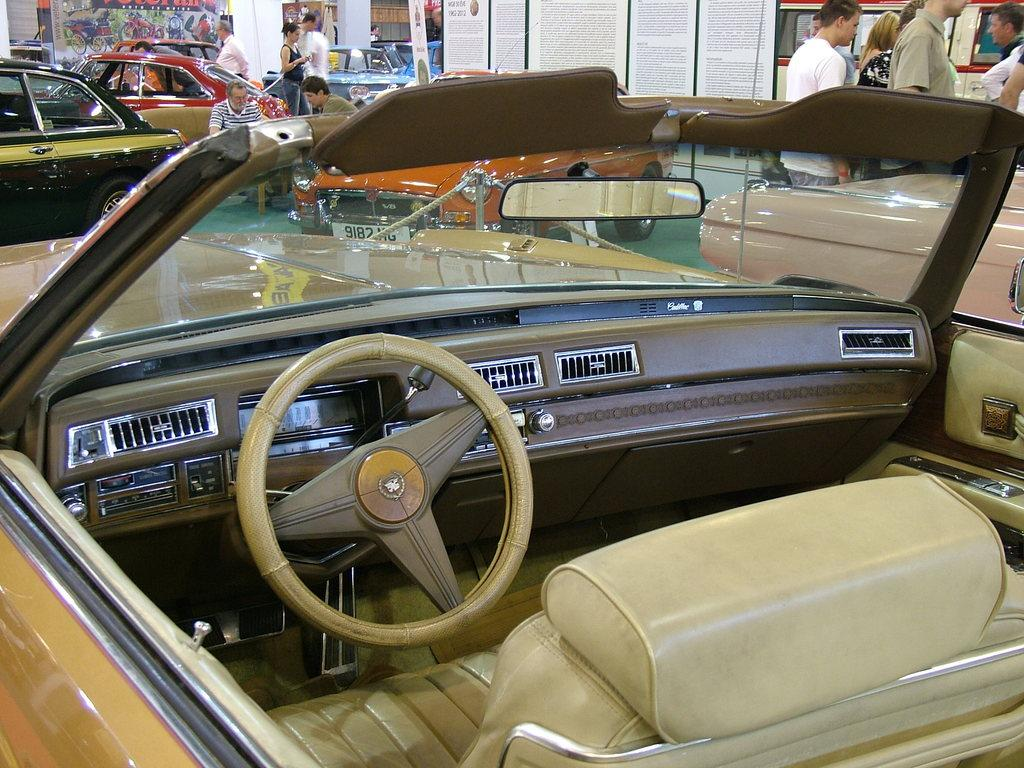What is the main subject of the image? The main subject of the image is many cars. Are there any people present in the image? Yes, there are people in the image. What are the people on the right side of the image doing? The people on the right side of the image are walking. What can be seen in the middle of the image? There is a poster in the middle of the image. What type of coil is being used to reward the detail in the image? There is no coil or reward present in the image; it features cars, people, and a poster. 